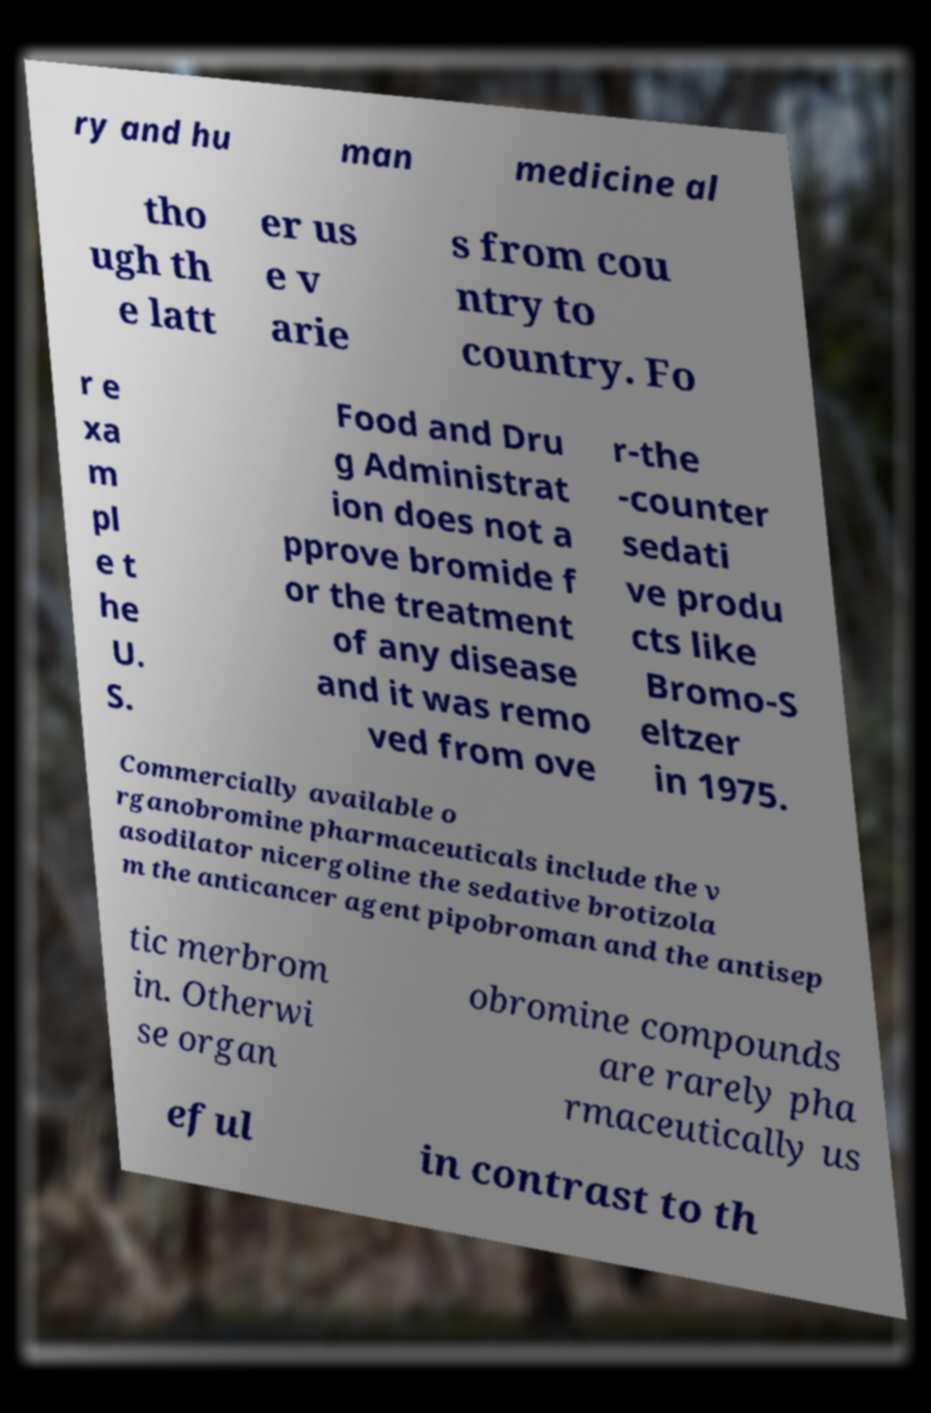For documentation purposes, I need the text within this image transcribed. Could you provide that? ry and hu man medicine al tho ugh th e latt er us e v arie s from cou ntry to country. Fo r e xa m pl e t he U. S. Food and Dru g Administrat ion does not a pprove bromide f or the treatment of any disease and it was remo ved from ove r-the -counter sedati ve produ cts like Bromo-S eltzer in 1975. Commercially available o rganobromine pharmaceuticals include the v asodilator nicergoline the sedative brotizola m the anticancer agent pipobroman and the antisep tic merbrom in. Otherwi se organ obromine compounds are rarely pha rmaceutically us eful in contrast to th 